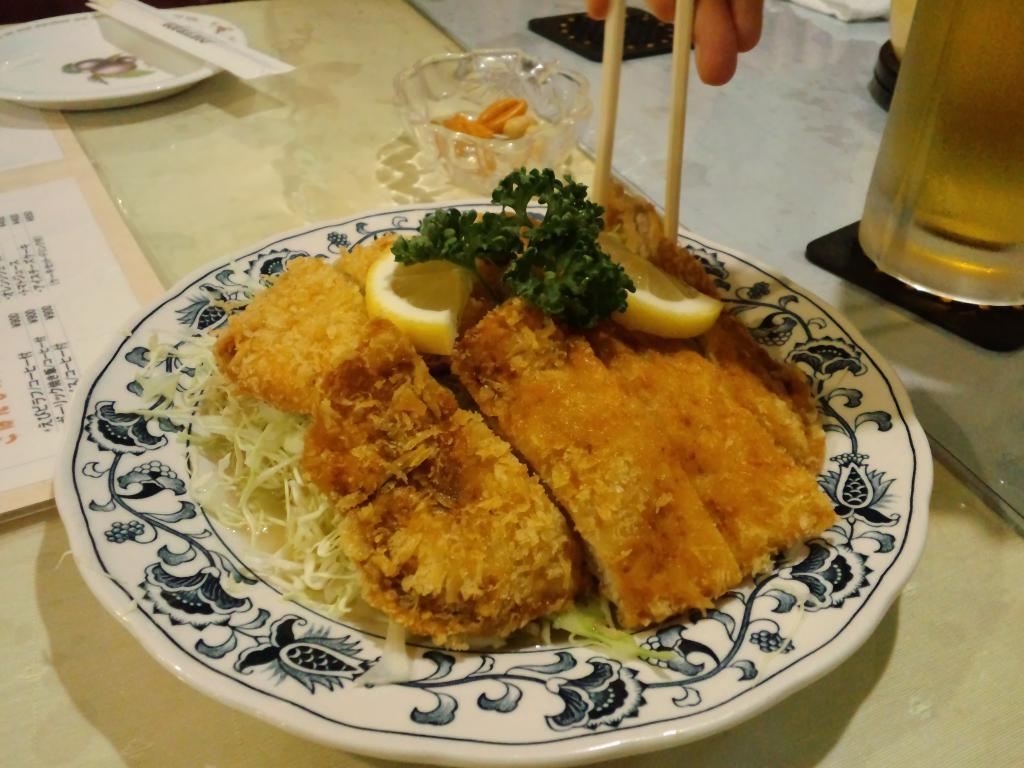What piece of furniture is present in the image? There is a table in the image. What is placed on the table? There is a plate on the table. What is on the plate? The plate contains food items. Are there any other objects on the table besides the plate? Yes, there are other objects on the table. Whose hand is visible in the image? A person's hand is visible at the top of the image. What type of powder is being sprinkled on the clam in the image? There is no clam or powder present in the image. 